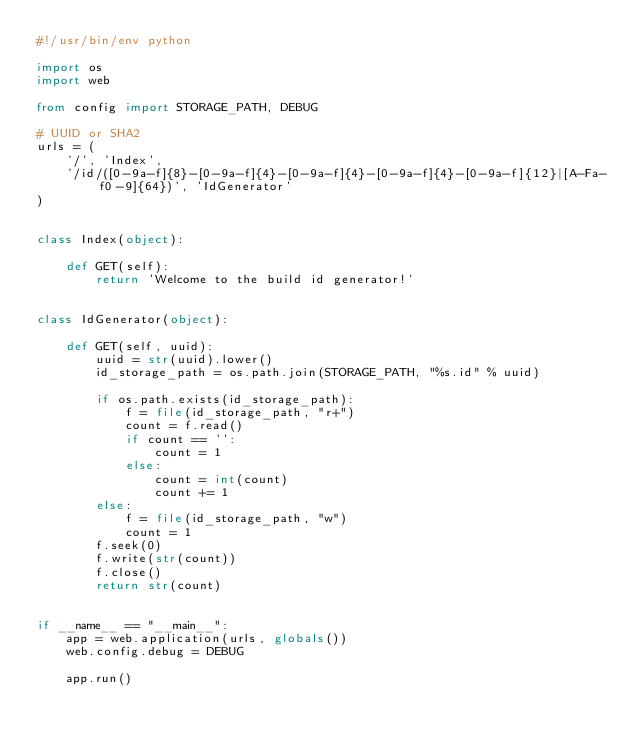<code> <loc_0><loc_0><loc_500><loc_500><_Python_>#!/usr/bin/env python

import os
import web

from config import STORAGE_PATH, DEBUG

# UUID or SHA2
urls = (
    '/', 'Index',
    '/id/([0-9a-f]{8}-[0-9a-f]{4}-[0-9a-f]{4}-[0-9a-f]{4}-[0-9a-f]{12}|[A-Fa-f0-9]{64})', 'IdGenerator'
)


class Index(object):

    def GET(self):
        return 'Welcome to the build id generator!'


class IdGenerator(object):

    def GET(self, uuid):
        uuid = str(uuid).lower()
        id_storage_path = os.path.join(STORAGE_PATH, "%s.id" % uuid)

        if os.path.exists(id_storage_path):
            f = file(id_storage_path, "r+")
            count = f.read()
            if count == '':
                count = 1
            else:
                count = int(count)
                count += 1
        else:
            f = file(id_storage_path, "w")
            count = 1
        f.seek(0)
        f.write(str(count))
        f.close()
        return str(count)


if __name__ == "__main__":
    app = web.application(urls, globals())
    web.config.debug = DEBUG

    app.run()
</code> 